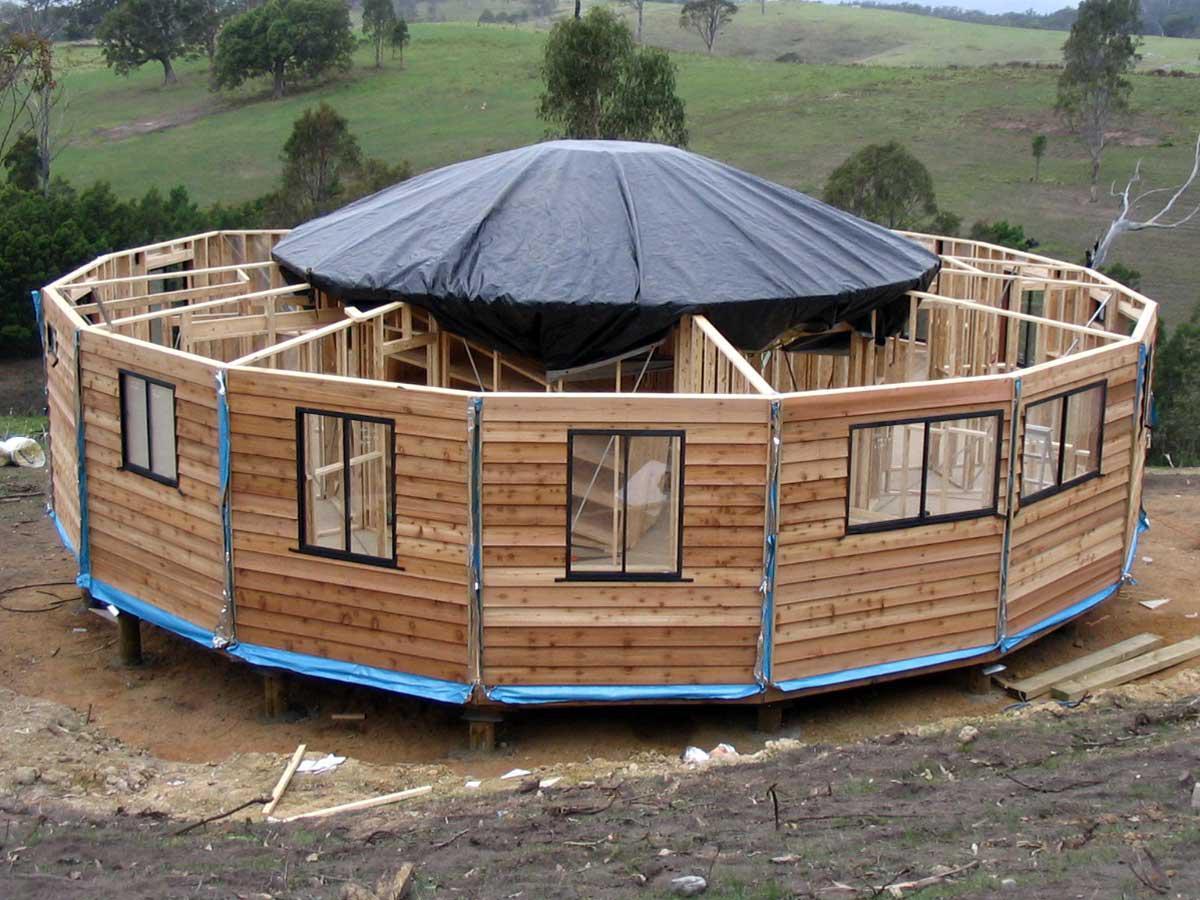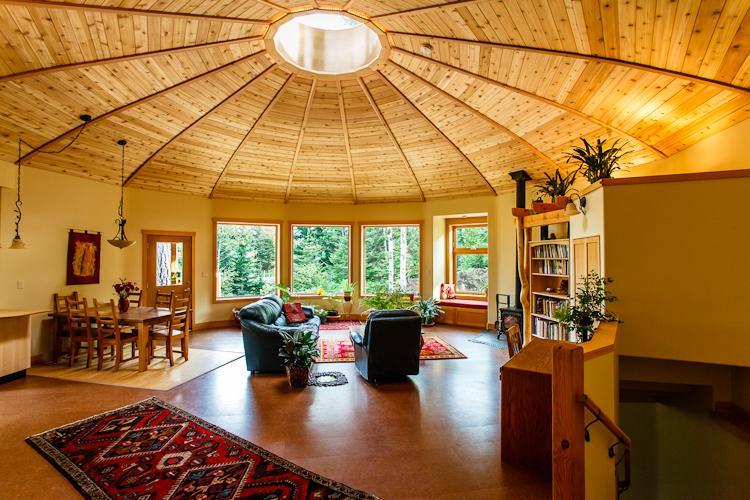The first image is the image on the left, the second image is the image on the right. Given the left and right images, does the statement "In one image, a round wooden house is under construction with an incomplete roof." hold true? Answer yes or no. Yes. 